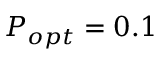Convert formula to latex. <formula><loc_0><loc_0><loc_500><loc_500>P _ { o p t } = 0 . 1</formula> 